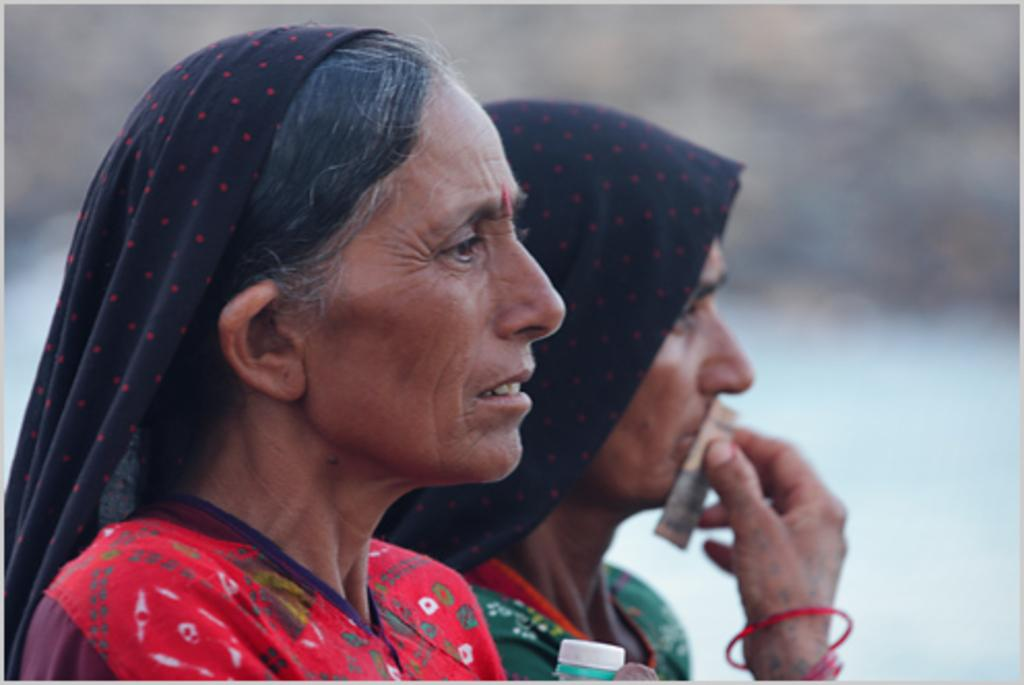How many people are present in the image? There are two women in the image. Can you describe the background of the image? The background of the image is blurred. How many bells can be heard ringing in the image? There are no bells present in the image, and therefore no sound can be heard. What type of boot is visible on the foot of one of the women in the image? There is no boot visible on the foot of either woman in the image. 